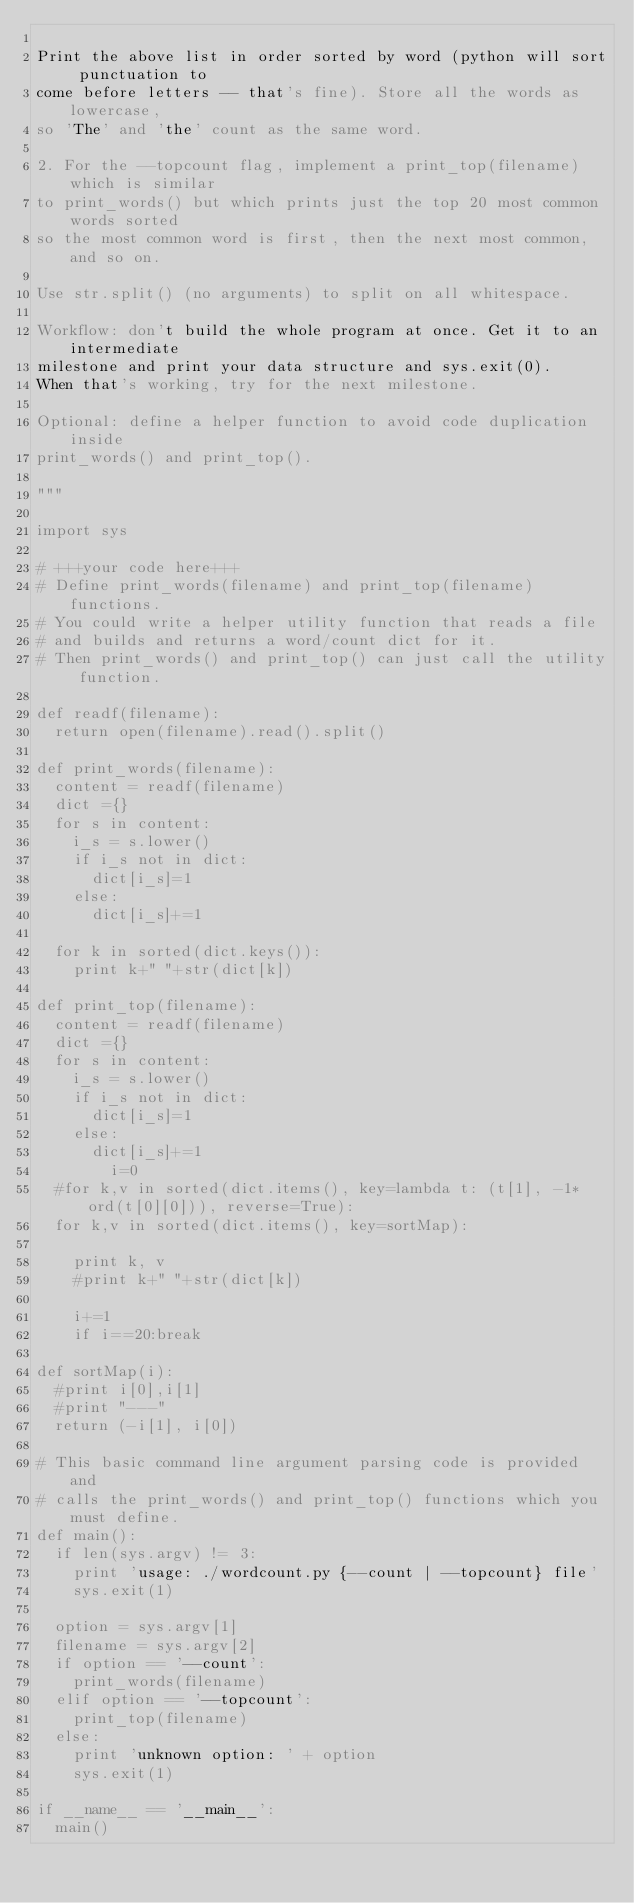<code> <loc_0><loc_0><loc_500><loc_500><_Python_>
Print the above list in order sorted by word (python will sort punctuation to
come before letters -- that's fine). Store all the words as lowercase,
so 'The' and 'the' count as the same word.

2. For the --topcount flag, implement a print_top(filename) which is similar
to print_words() but which prints just the top 20 most common words sorted
so the most common word is first, then the next most common, and so on.

Use str.split() (no arguments) to split on all whitespace.

Workflow: don't build the whole program at once. Get it to an intermediate
milestone and print your data structure and sys.exit(0).
When that's working, try for the next milestone.

Optional: define a helper function to avoid code duplication inside
print_words() and print_top().

"""

import sys

# +++your code here+++
# Define print_words(filename) and print_top(filename) functions.
# You could write a helper utility function that reads a file
# and builds and returns a word/count dict for it.
# Then print_words() and print_top() can just call the utility function.

def readf(filename):
	return open(filename).read().split()

def print_words(filename):
	content = readf(filename)
	dict ={}
	for s in content:
		i_s = s.lower()
		if i_s not in dict:
			dict[i_s]=1
		else:
			dict[i_s]+=1	 

	for k in sorted(dict.keys()):
		print k+" "+str(dict[k])

def print_top(filename):
	content = readf(filename)
	dict ={}
	for s in content:
		i_s = s.lower()
		if i_s not in dict:
			dict[i_s]=1
		else:
			dict[i_s]+=1	 
        i=0
	#for k,v in sorted(dict.items(), key=lambda t: (t[1], -1* ord(t[0][0])), reverse=True):
	for k,v in sorted(dict.items(), key=sortMap):

		print k, v
		#print k+" "+str(dict[k])

		i+=1
		if i==20:break

def sortMap(i):
	#print i[0],i[1]
	#print "---"
	return (-i[1], i[0])

# This basic command line argument parsing code is provided and
# calls the print_words() and print_top() functions which you must define.
def main():
  if len(sys.argv) != 3:
    print 'usage: ./wordcount.py {--count | --topcount} file'
    sys.exit(1)

  option = sys.argv[1]
  filename = sys.argv[2]
  if option == '--count':
    print_words(filename)
  elif option == '--topcount':
    print_top(filename)
  else:
    print 'unknown option: ' + option
    sys.exit(1)

if __name__ == '__main__':
  main()
</code> 